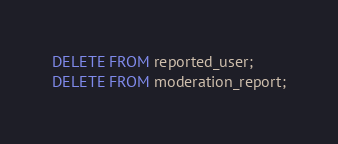<code> <loc_0><loc_0><loc_500><loc_500><_SQL_>DELETE FROM reported_user;
DELETE FROM moderation_report;
</code> 